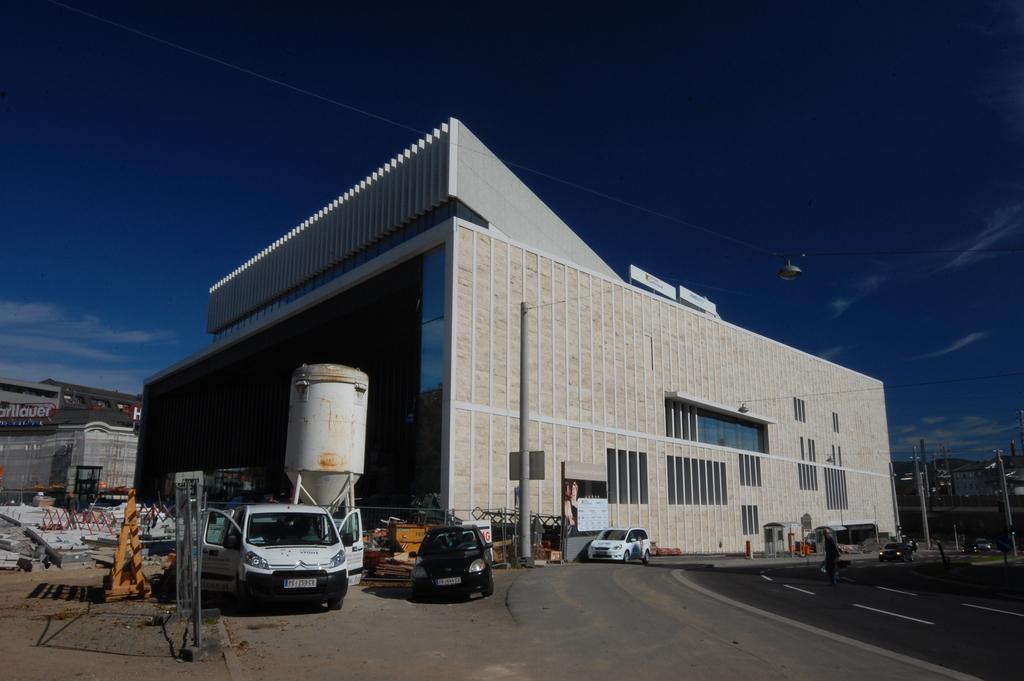Describe this image in one or two sentences. In the picture we can see a building which is with a shed which is white in color and near to it, we can see some vehicles on the path and some cylindrical chambers on the vehicle and in the background we can see a sky which is blue in color. 